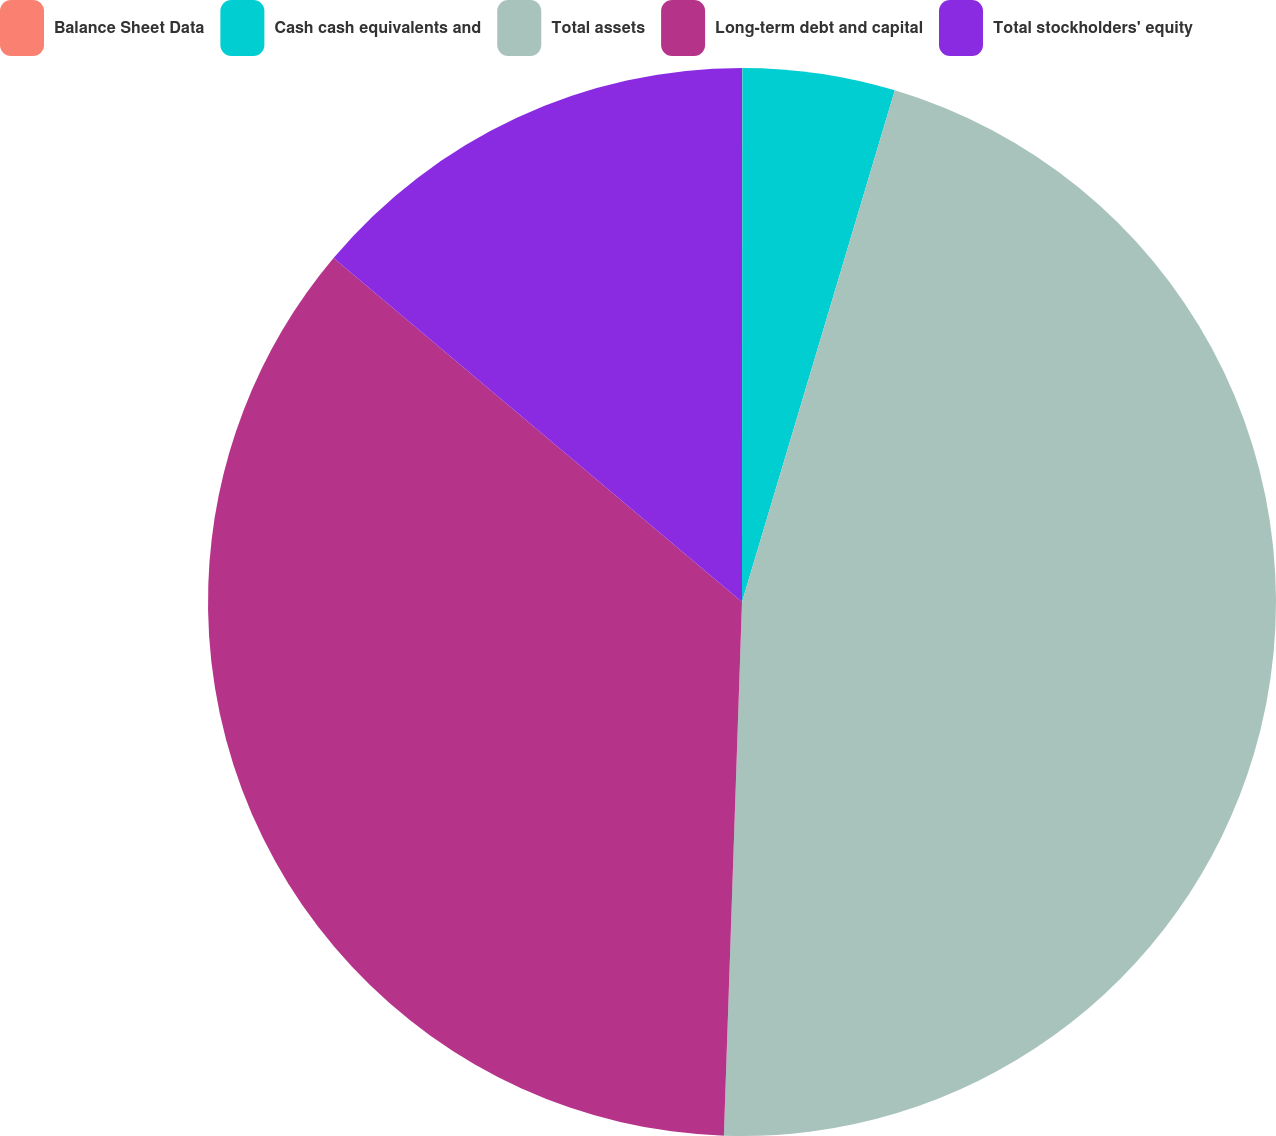<chart> <loc_0><loc_0><loc_500><loc_500><pie_chart><fcel>Balance Sheet Data<fcel>Cash cash equivalents and<fcel>Total assets<fcel>Long-term debt and capital<fcel>Total stockholders' equity<nl><fcel>0.01%<fcel>4.61%<fcel>45.92%<fcel>35.6%<fcel>13.86%<nl></chart> 